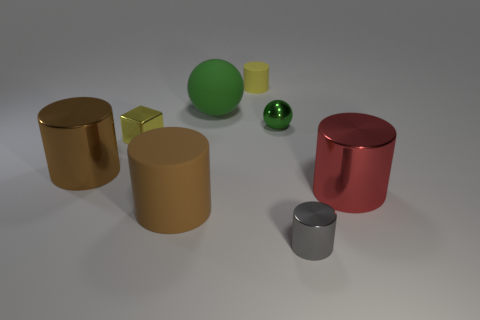Is there a purple ball?
Make the answer very short. No. Is the small gray thing made of the same material as the yellow object that is in front of the large green rubber sphere?
Keep it short and to the point. Yes. What is the material of the yellow cylinder that is the same size as the metallic ball?
Provide a succinct answer. Rubber. Are there any big red cylinders made of the same material as the small yellow block?
Provide a short and direct response. Yes. There is a big matte object that is to the left of the large rubber thing behind the shiny cube; is there a big rubber sphere in front of it?
Offer a very short reply. No. The other metal thing that is the same size as the brown metal thing is what shape?
Ensure brevity in your answer.  Cylinder. Is the size of the shiny object in front of the red cylinder the same as the cylinder that is behind the brown metal cylinder?
Your answer should be very brief. Yes. What number of small red metallic cylinders are there?
Make the answer very short. 0. What size is the brown thing that is in front of the big metal thing to the right of the tiny yellow cylinder that is behind the big red metal cylinder?
Your answer should be compact. Large. Is the tiny shiny sphere the same color as the block?
Provide a short and direct response. No. 